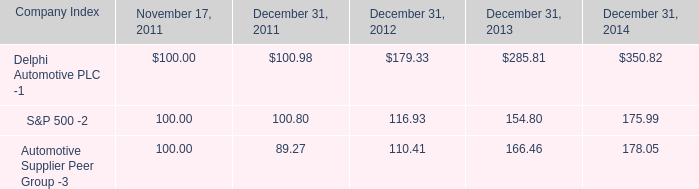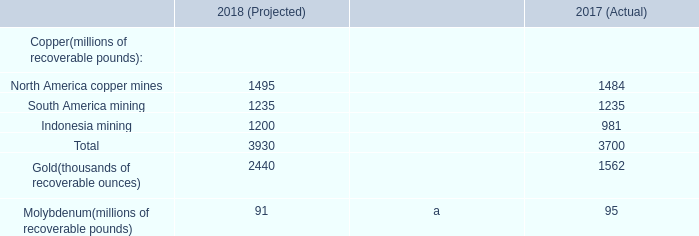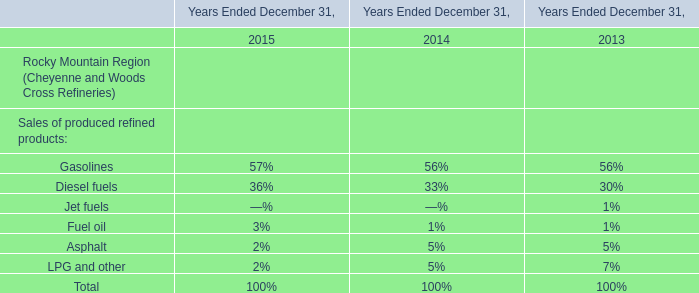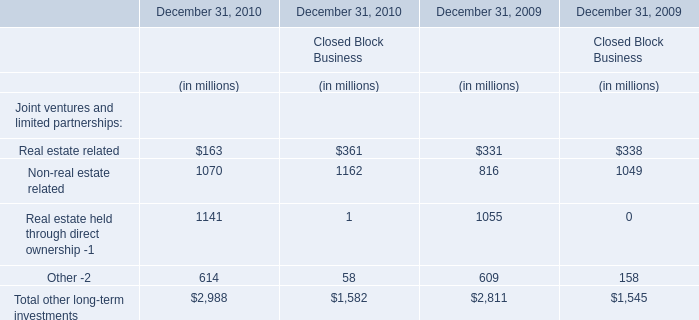what was the percentage total return for delphi automotive plc for the five years ended december 31 2014?\\n 
Computations: ((350.82 - 100) / 100)
Answer: 2.5082. 